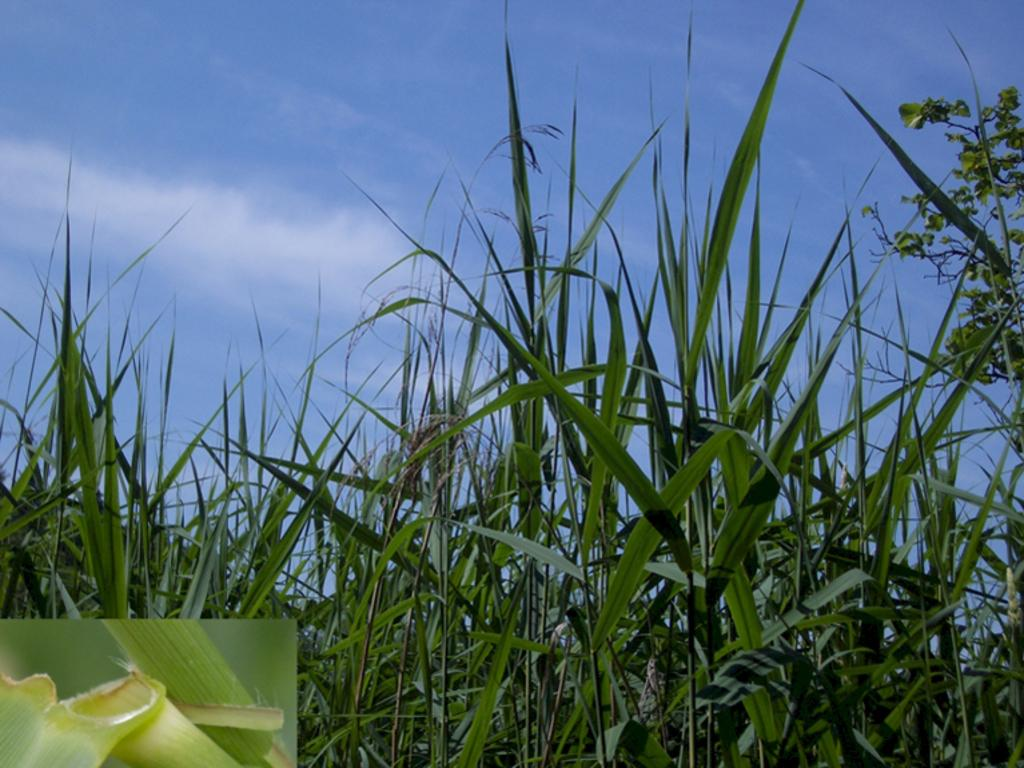What type of plants are visible in the image? There are green plants in the image. What colors can be seen in the sky in the image? The sky is blue and white in color. Can you see a quill being used to write in the image? There is no quill present in the image. Is there a river flowing through the image? There is no river visible in the image. 